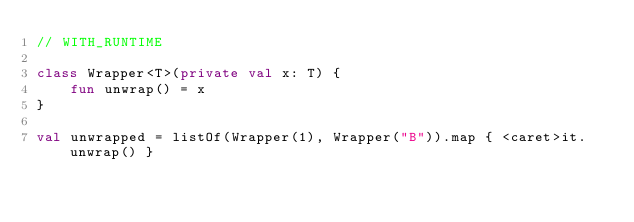Convert code to text. <code><loc_0><loc_0><loc_500><loc_500><_Kotlin_>// WITH_RUNTIME

class Wrapper<T>(private val x: T) {
    fun unwrap() = x
}

val unwrapped = listOf(Wrapper(1), Wrapper("B")).map { <caret>it.unwrap() }</code> 